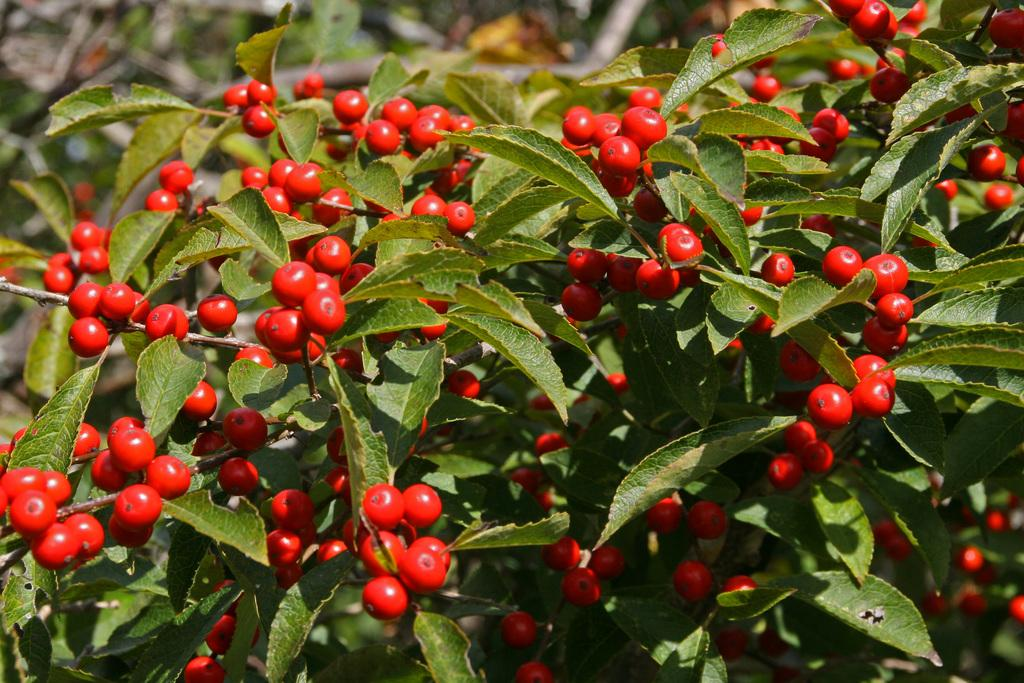What color are the fruits in the image? The fruits in the image are red. What other elements can be seen in the image besides the fruits? There are green leaves and stems in the image. How would you describe the background of the image? The background of the image is blurry. Where is the cat sleeping in the image? There is no cat present in the image. What type of lunch is being served in the image? There is no lunch being served in the image; it features fruits, leaves, and stems. 